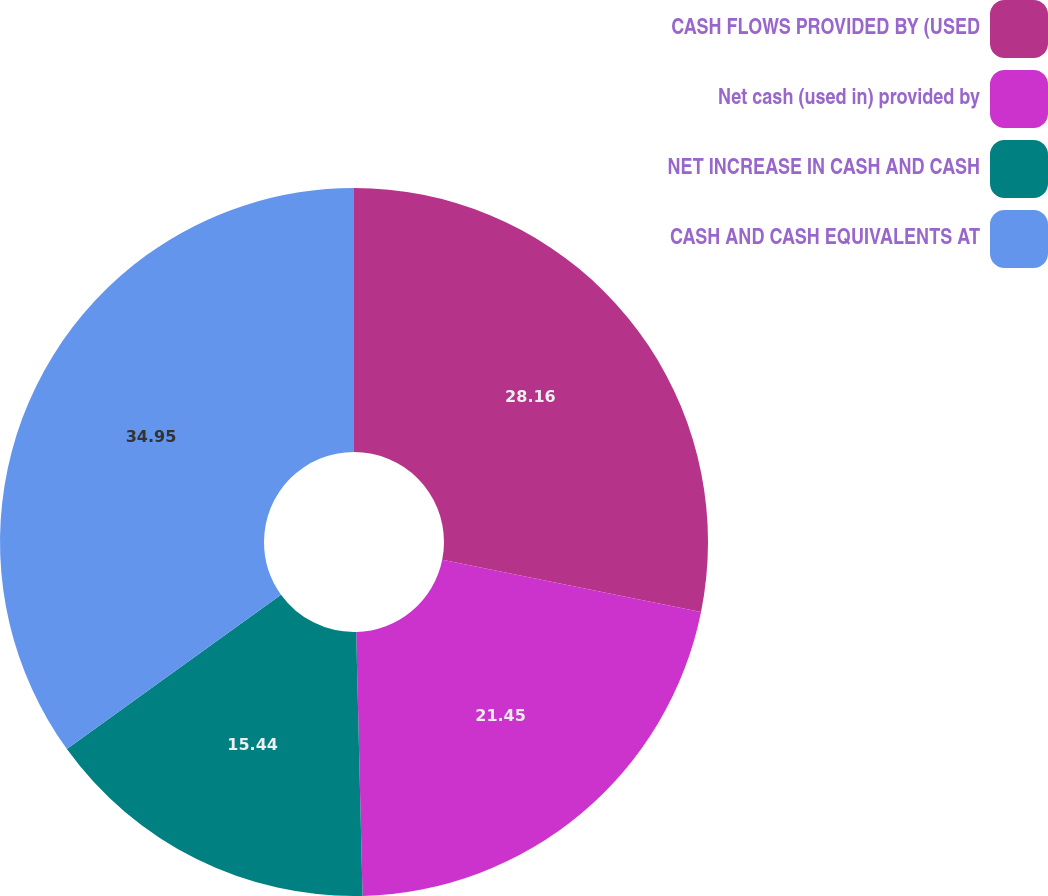Convert chart to OTSL. <chart><loc_0><loc_0><loc_500><loc_500><pie_chart><fcel>CASH FLOWS PROVIDED BY (USED<fcel>Net cash (used in) provided by<fcel>NET INCREASE IN CASH AND CASH<fcel>CASH AND CASH EQUIVALENTS AT<nl><fcel>28.16%<fcel>21.45%<fcel>15.44%<fcel>34.94%<nl></chart> 